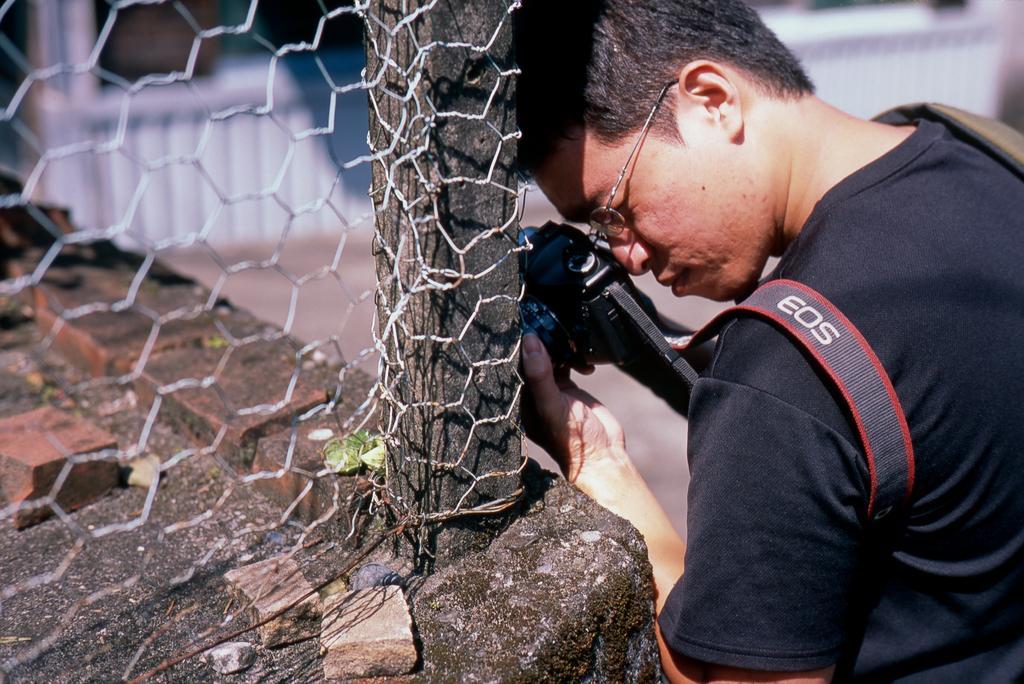Please provide a concise description of this image. This image consists of a fence and a person on the right side. He is holding a camera. He is wearing specs. He is wearing black dress. 